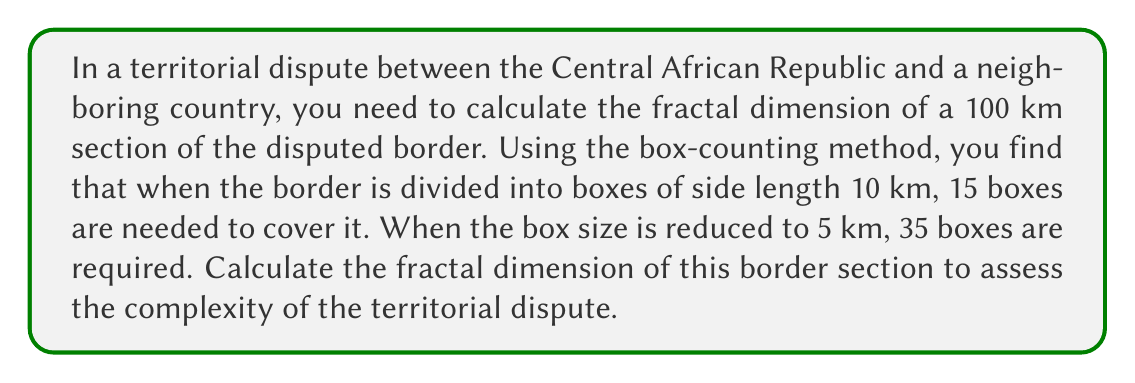Help me with this question. To calculate the fractal dimension using the box-counting method, we'll follow these steps:

1. Let's define our variables:
   $N_1 = 15$ (number of boxes for 10 km side length)
   $r_1 = 10$ km (first box size)
   $N_2 = 35$ (number of boxes for 5 km side length)
   $r_2 = 5$ km (second box size)

2. The fractal dimension $D$ is given by the formula:

   $$D = \frac{\log(N_2/N_1)}{\log(r_1/r_2)}$$

3. Let's substitute our values:

   $$D = \frac{\log(35/15)}{\log(10/5)}$$

4. Simplify the fractions inside the logarithms:

   $$D = \frac{\log(7/3)}{\log(2)}$$

5. Calculate the logarithms:

   $$D = \frac{0.847297860387}{\log(2)} = \frac{0.847297860387}{0.693147180560}$$

6. Perform the division:

   $$D \approx 1.222938734$$

The fractal dimension lies between 1 (a straight line) and 2 (a filled plane). A value closer to 1 indicates a simpler border, while a value closer to 2 suggests a more complex, irregular border.
Answer: $D \approx 1.22$ 